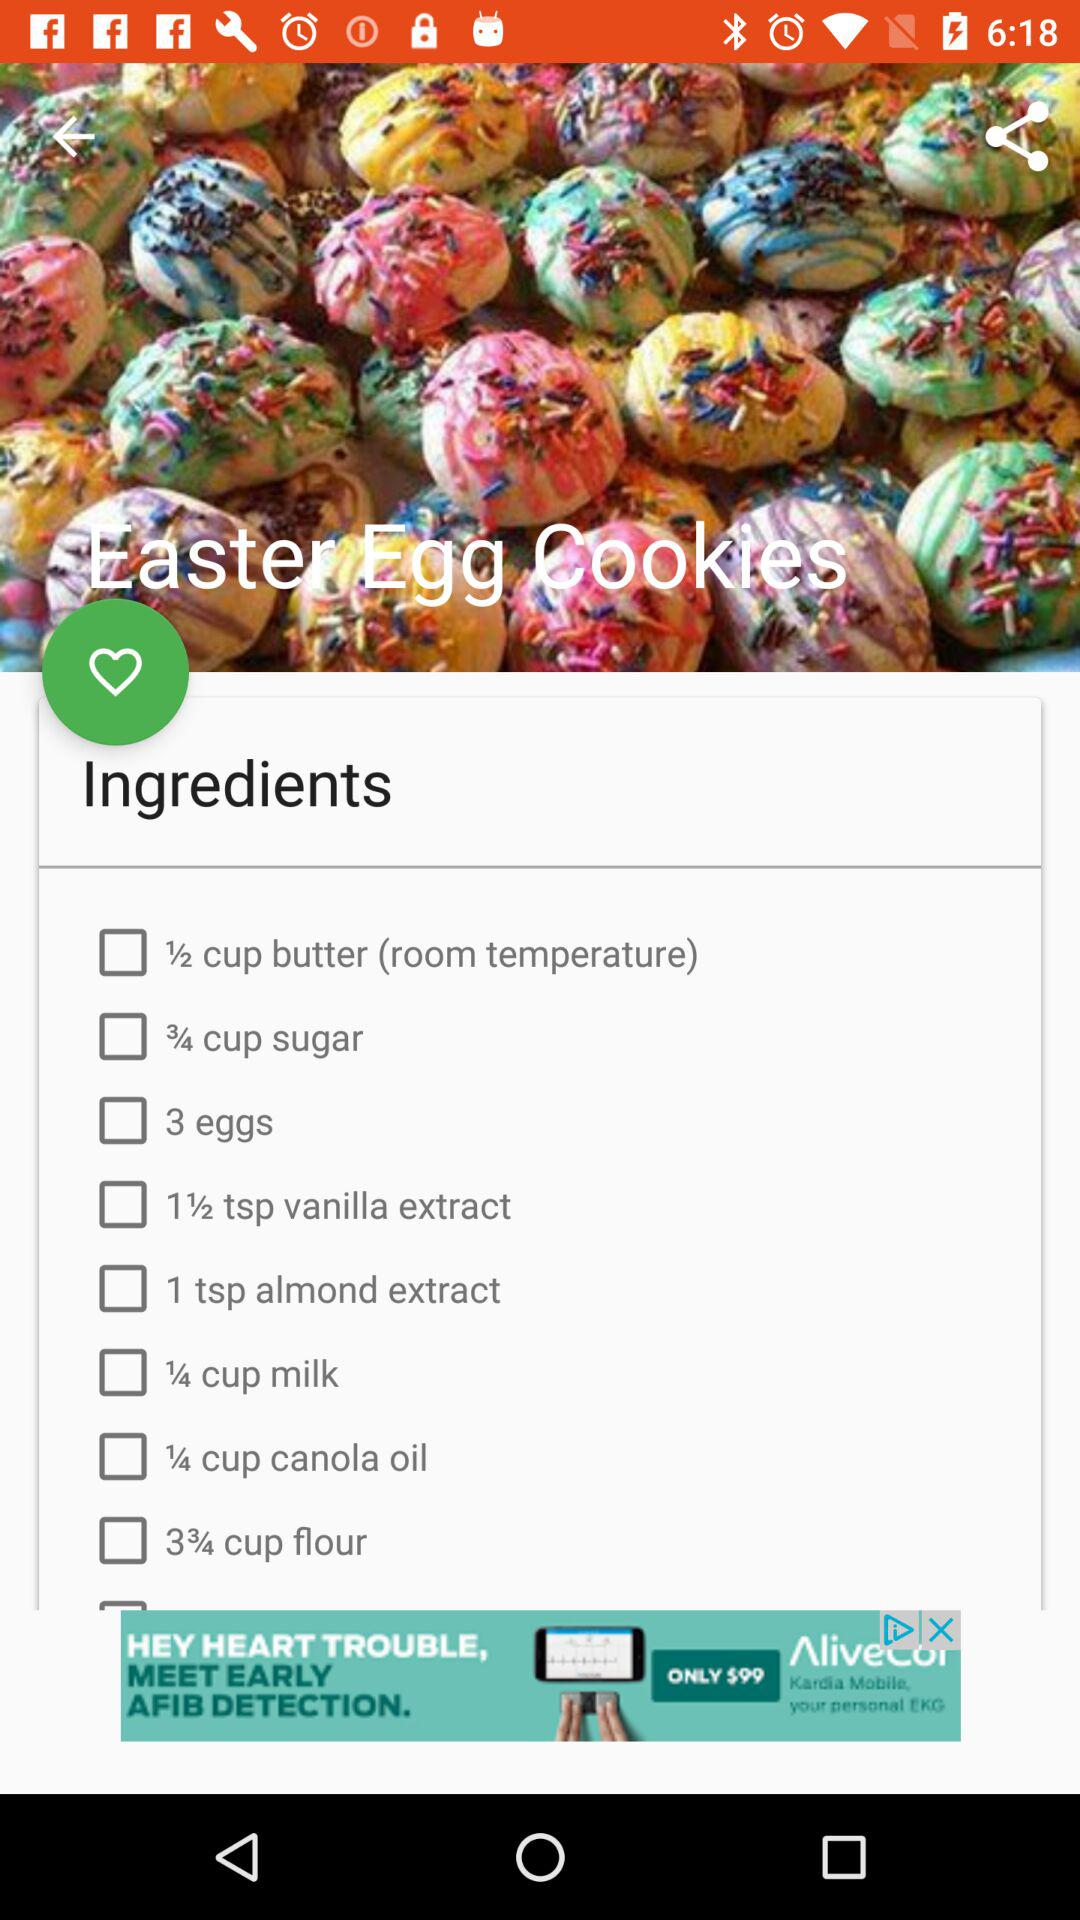How many eggs are required for the dish? The number of required eggs is 3. 